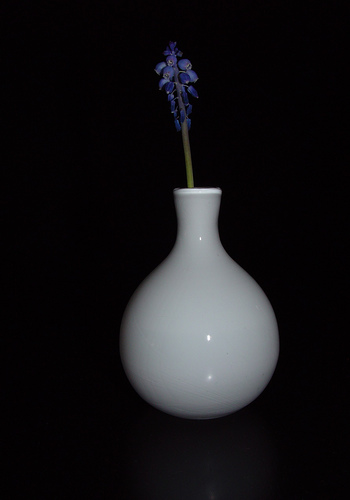How many items are red? In the image, there are no completely red items; however, the blue flower on the stem seems to have small patches of red near its base. It's slightly misleading to immediately notice, but on a closer look, one can observe these subtle hues. 